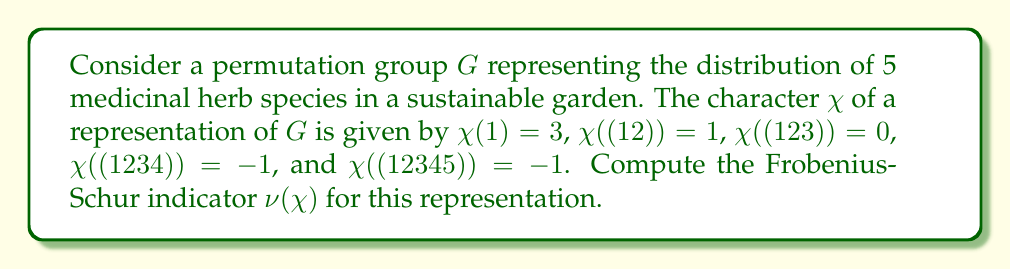Solve this math problem. To compute the Frobenius-Schur indicator $\nu(\chi)$ for the given representation, we'll follow these steps:

1) The Frobenius-Schur indicator is defined as:

   $$\nu(\chi) = \frac{1}{|G|} \sum_{g \in G} \chi(g^2)$$

2) For the symmetric group $S_5$, which represents the permutations of 5 elements, we have $|G| = 5! = 120$.

3) We need to consider all elements $g \in G$ and their squares $g^2$:
   - Identity (1): $(1)^2 = (1)$
   - Transpositions (12): $(12)^2 = (1)$
   - 3-cycles (123): $(123)^2 = (132)$
   - 4-cycles (1234): $(1234)^2 = (13)(24)$
   - 5-cycles (12345): $(12345)^2 = (13524)$

4) Now, we count the occurrences of each cycle type and multiply by the corresponding character value:
   - 1 identity element: $1 \cdot \chi(1) = 1 \cdot 3 = 3$
   - 10 transpositions: $10 \cdot \chi(1) = 10 \cdot 3 = 30$
   - 20 3-cycles: $20 \cdot \chi((123)) = 20 \cdot 0 = 0$
   - 30 4-cycles: $30 \cdot \chi((12)(34)) = 30 \cdot 1 = 30$
   - 24 5-cycles: $24 \cdot \chi((12345)) = 24 \cdot (-1) = -24$

5) Sum up all these values:

   $$3 + 30 + 0 + 30 - 24 = 39$$

6) Finally, divide by $|G| = 120$:

   $$\nu(\chi) = \frac{1}{120} \cdot 39 = \frac{13}{40}$$
Answer: $\frac{13}{40}$ 